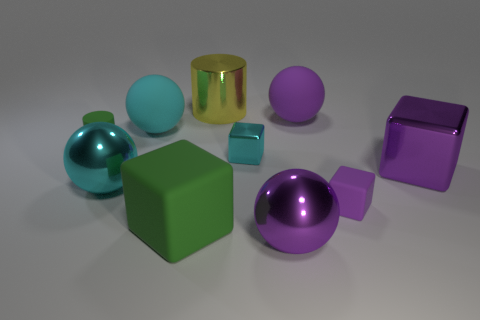Is the large matte cube the same color as the tiny matte cylinder?
Offer a very short reply. Yes. There is a large block that is the same color as the tiny rubber cylinder; what material is it?
Provide a succinct answer. Rubber. The rubber object that is both in front of the cyan metallic cube and left of the large purple rubber thing is what color?
Your response must be concise. Green. Is the color of the rubber sphere that is left of the tiny metal thing the same as the small metallic object?
Offer a very short reply. Yes. There is a yellow shiny thing that is the same size as the purple metal block; what shape is it?
Provide a succinct answer. Cylinder. What number of other things are there of the same color as the metallic cylinder?
Your answer should be very brief. 0. How many other things are made of the same material as the small cylinder?
Your answer should be compact. 4. There is a green matte cylinder; does it have the same size as the green block that is to the left of the small cyan thing?
Ensure brevity in your answer.  No. The tiny metallic object is what color?
Ensure brevity in your answer.  Cyan. What is the shape of the small rubber object to the left of the big purple metal object in front of the big thing that is on the left side of the big cyan matte sphere?
Keep it short and to the point. Cylinder. 